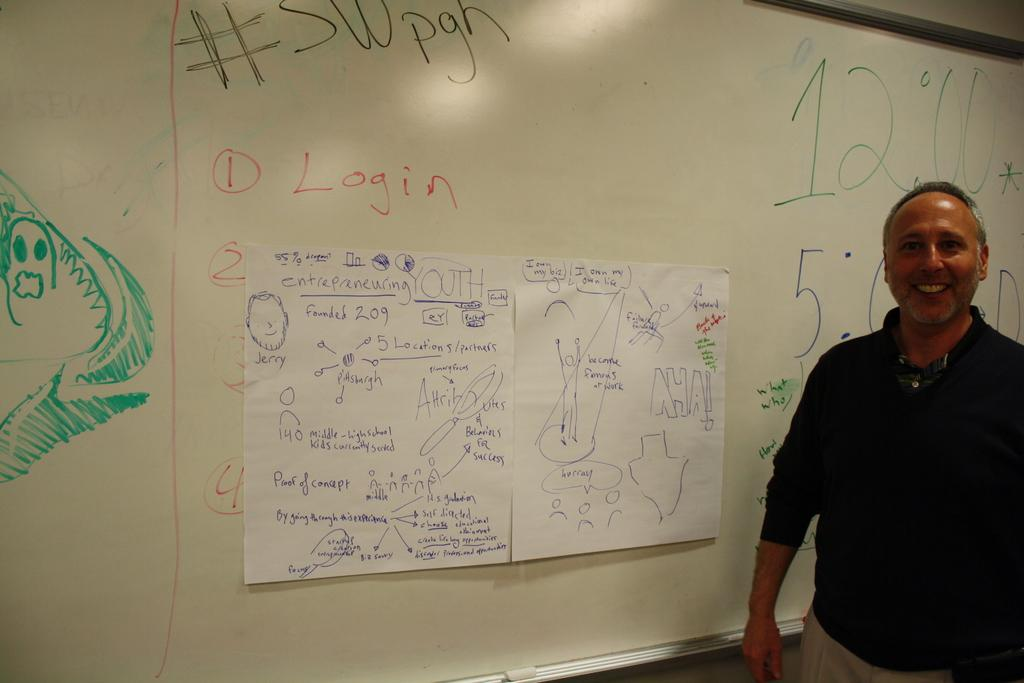<image>
Relay a brief, clear account of the picture shown. A man is in front of a whiteboard 2 pages taped to the board under the word Login. 